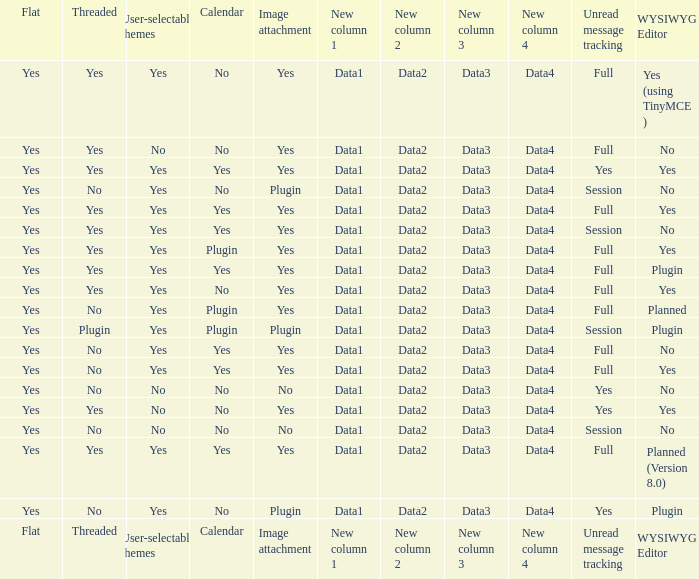Which WYSIWYG Editor has an Image attachment of yes, and a Calendar of plugin? Yes, Planned. 